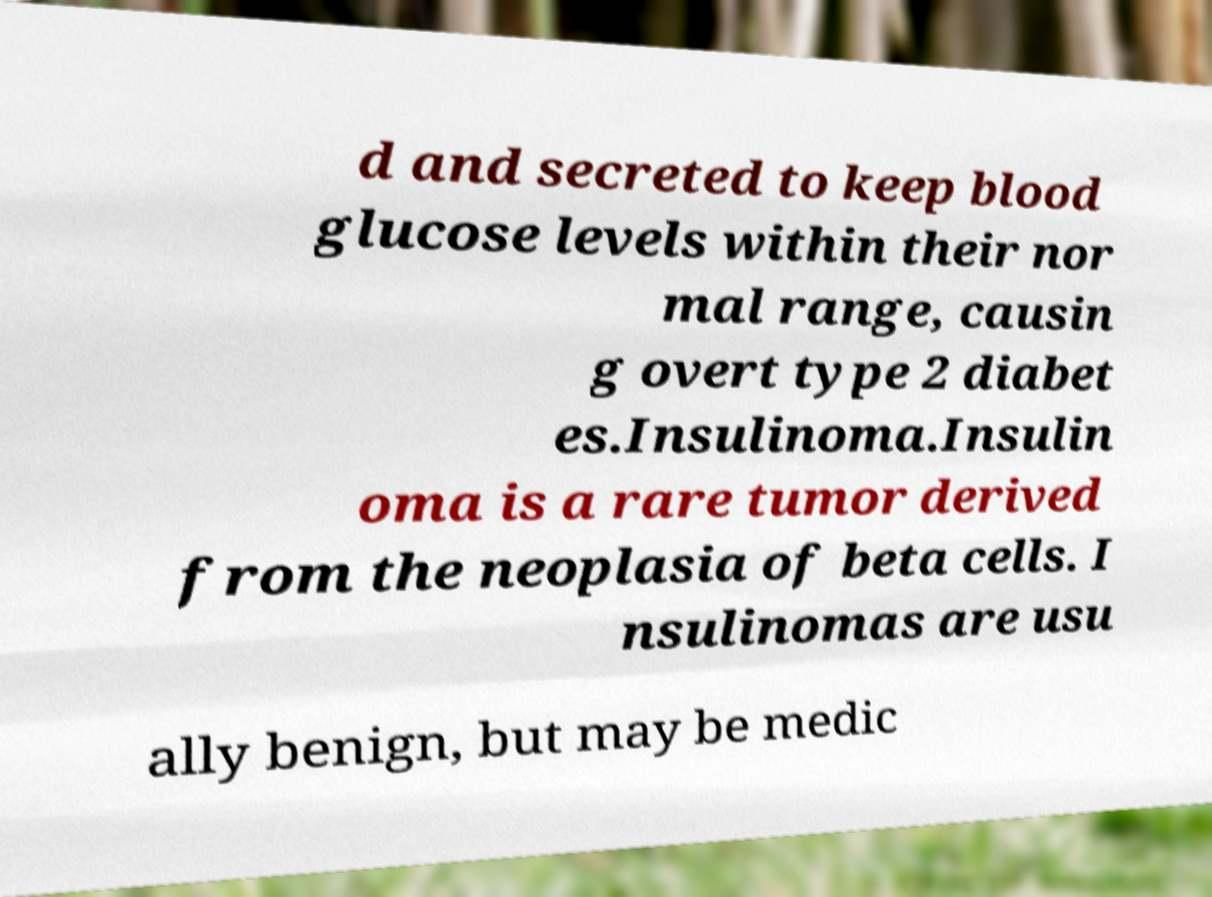Please identify and transcribe the text found in this image. d and secreted to keep blood glucose levels within their nor mal range, causin g overt type 2 diabet es.Insulinoma.Insulin oma is a rare tumor derived from the neoplasia of beta cells. I nsulinomas are usu ally benign, but may be medic 